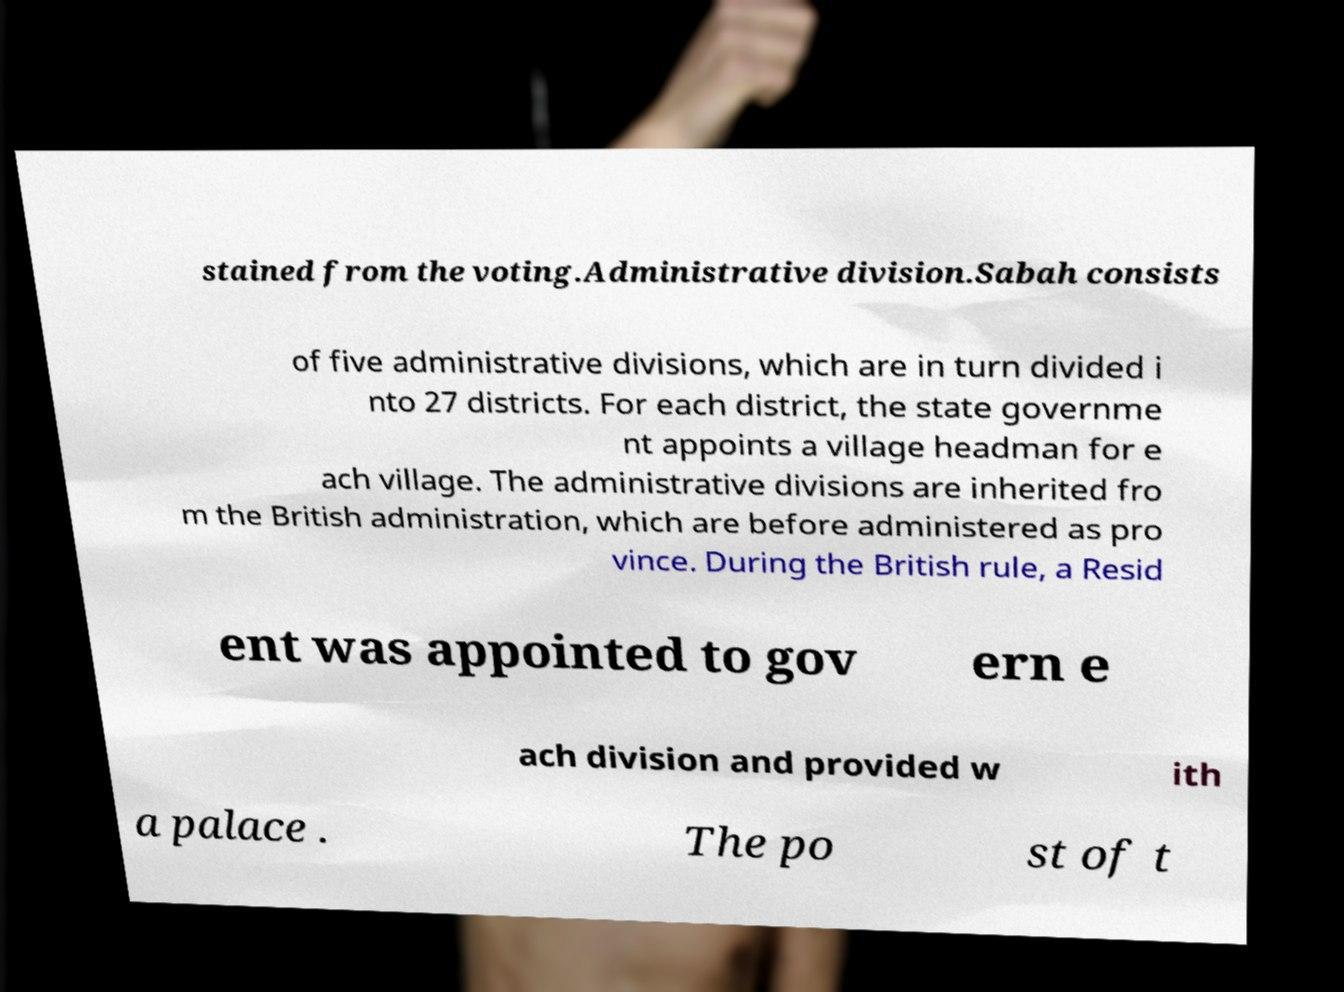What messages or text are displayed in this image? I need them in a readable, typed format. stained from the voting.Administrative division.Sabah consists of five administrative divisions, which are in turn divided i nto 27 districts. For each district, the state governme nt appoints a village headman for e ach village. The administrative divisions are inherited fro m the British administration, which are before administered as pro vince. During the British rule, a Resid ent was appointed to gov ern e ach division and provided w ith a palace . The po st of t 